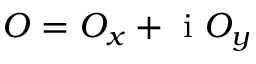<formula> <loc_0><loc_0><loc_500><loc_500>O = O _ { x } + i O _ { y }</formula> 